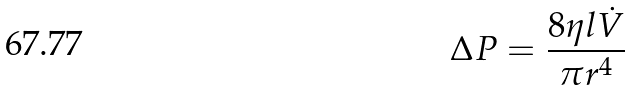<formula> <loc_0><loc_0><loc_500><loc_500>\Delta P = \frac { 8 \eta l \dot { V } } { \pi r ^ { 4 } }</formula> 